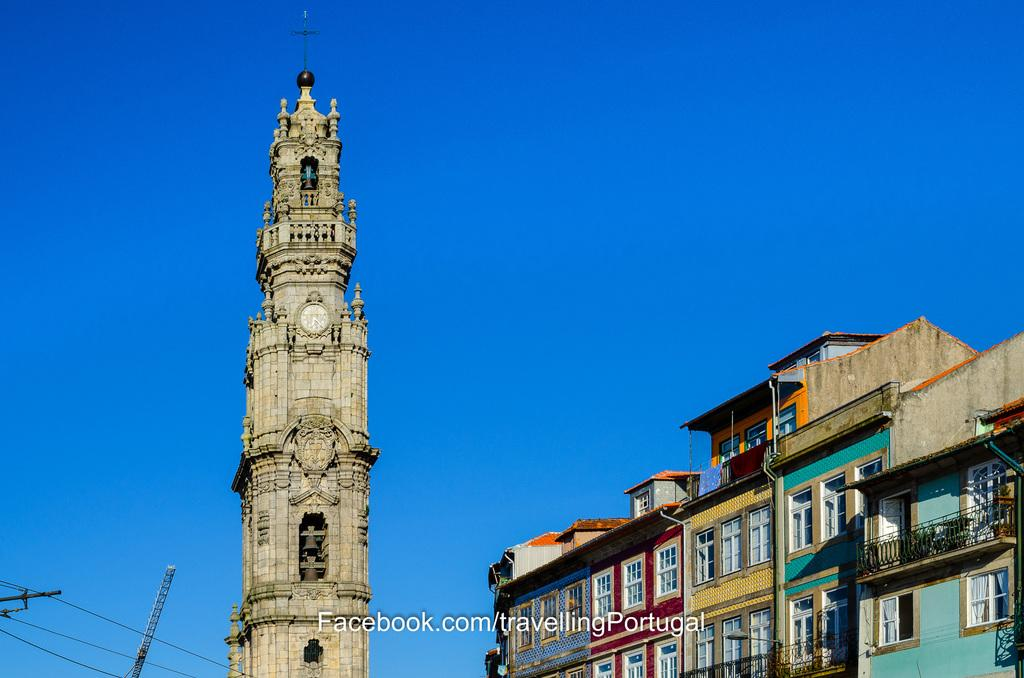What type of structures can be seen in the image? There are buildings in the image. What feature is common to many of the buildings in the image? There are windows in the image. What architectural element can be seen in the image? There is a railing in the image. What is the tallest structure in the image? There is a tower in the image. What symbol is present in the image? There is a cross symbol in the image. What type of infrastructure is visible in the image? There are wires visible in the image. What part of the natural environment is visible in the image? The sky is visible in the image. Can you tell me how many trays are being used by the grandmother in the image? There is no grandmother or tray present in the image. What type of business is being conducted in the image? The image does not depict any business activities. 